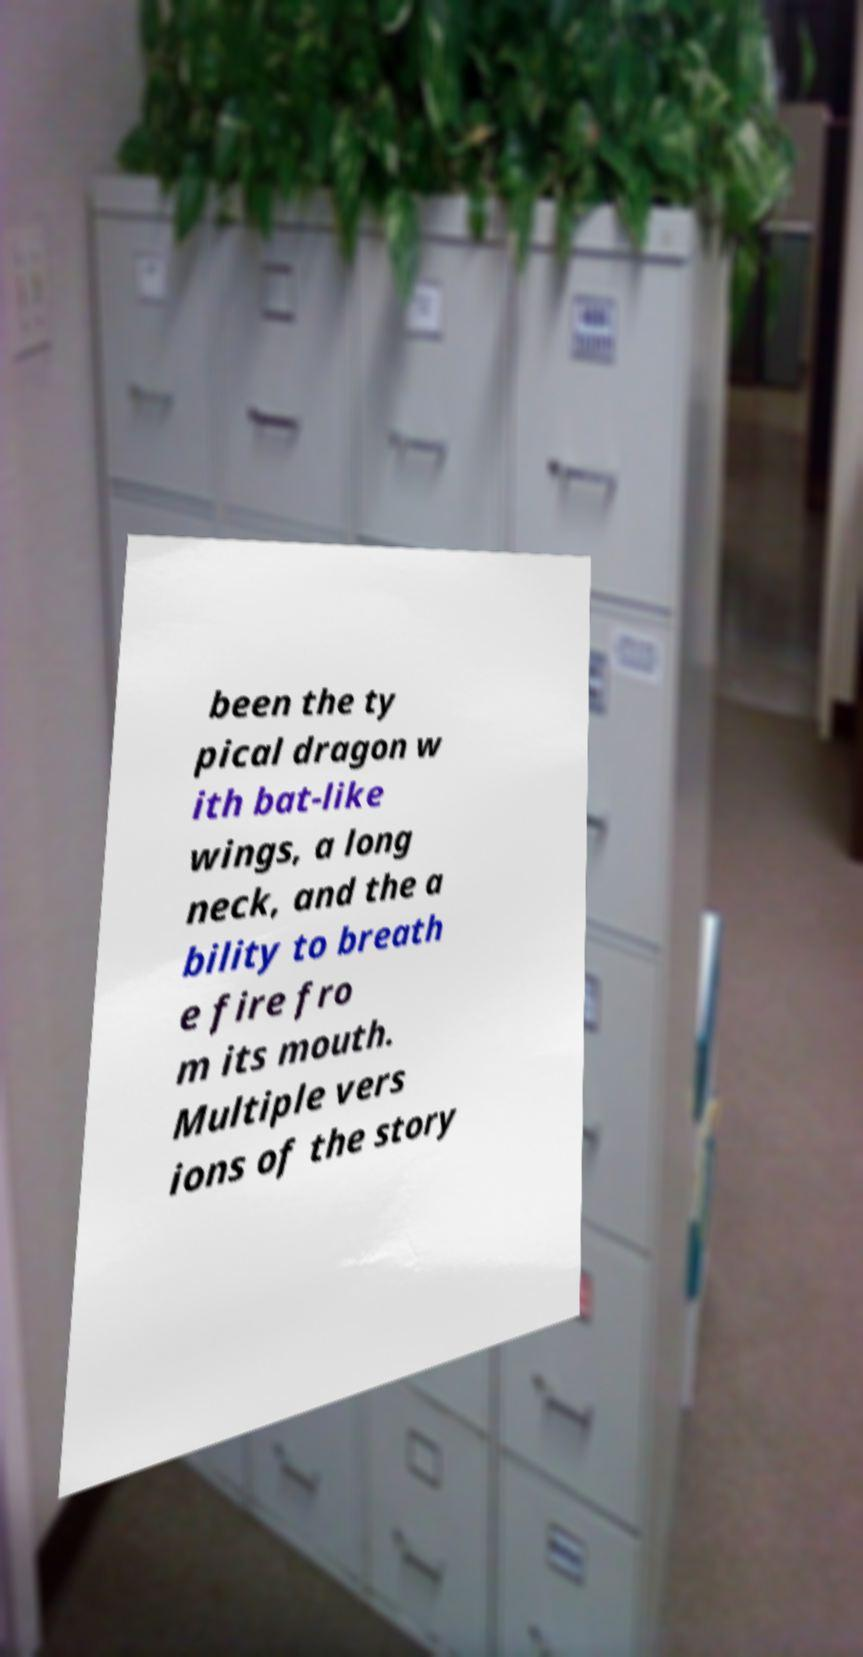There's text embedded in this image that I need extracted. Can you transcribe it verbatim? been the ty pical dragon w ith bat-like wings, a long neck, and the a bility to breath e fire fro m its mouth. Multiple vers ions of the story 